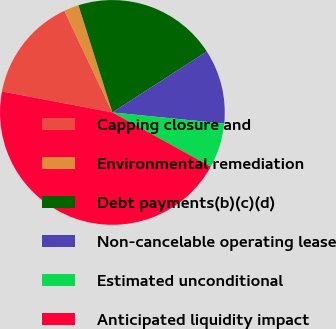Convert chart. <chart><loc_0><loc_0><loc_500><loc_500><pie_chart><fcel>Capping closure and<fcel>Environmental remediation<fcel>Debt payments(b)(c)(d)<fcel>Non-cancelable operating lease<fcel>Estimated unconditional<fcel>Anticipated liquidity impact<nl><fcel>14.99%<fcel>2.15%<fcel>20.75%<fcel>10.71%<fcel>6.43%<fcel>44.97%<nl></chart> 